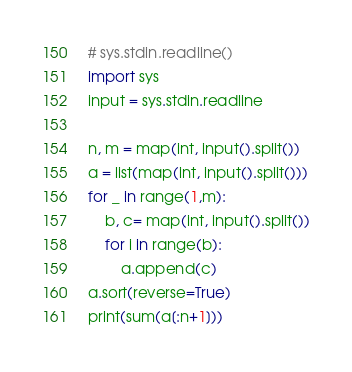<code> <loc_0><loc_0><loc_500><loc_500><_Python_># sys.stdin.readline()
import sys
input = sys.stdin.readline

n, m = map(int, input().split())
a = list(map(int, input().split()))
for _ in range(1,m):
    b, c= map(int, input().split())
    for i in range(b):
        a.append(c)
a.sort(reverse=True)
print(sum(a[:n+1]))</code> 